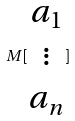<formula> <loc_0><loc_0><loc_500><loc_500>M [ \begin{matrix} a _ { 1 } \\ \vdots \\ a _ { n } \end{matrix} ]</formula> 